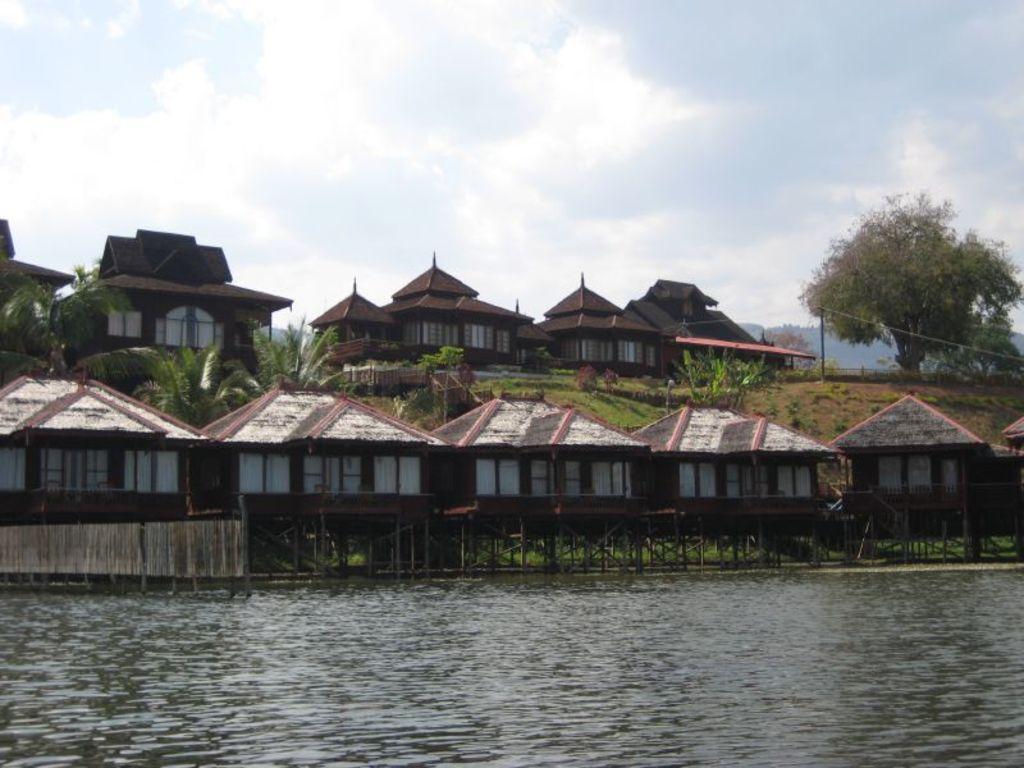Could you give a brief overview of what you see in this image? There is water. In the background, there are cottages which are having roofs, there are trees and clouds in the sky. 